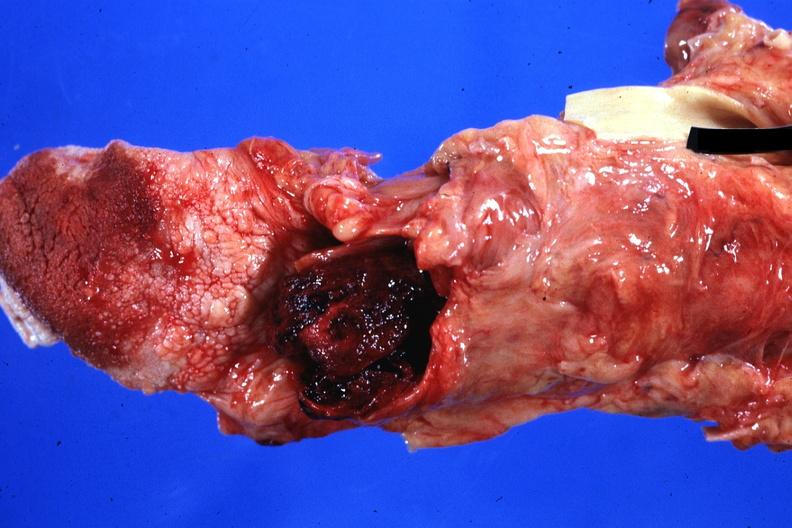s larynx present?
Answer the question using a single word or phrase. Yes 